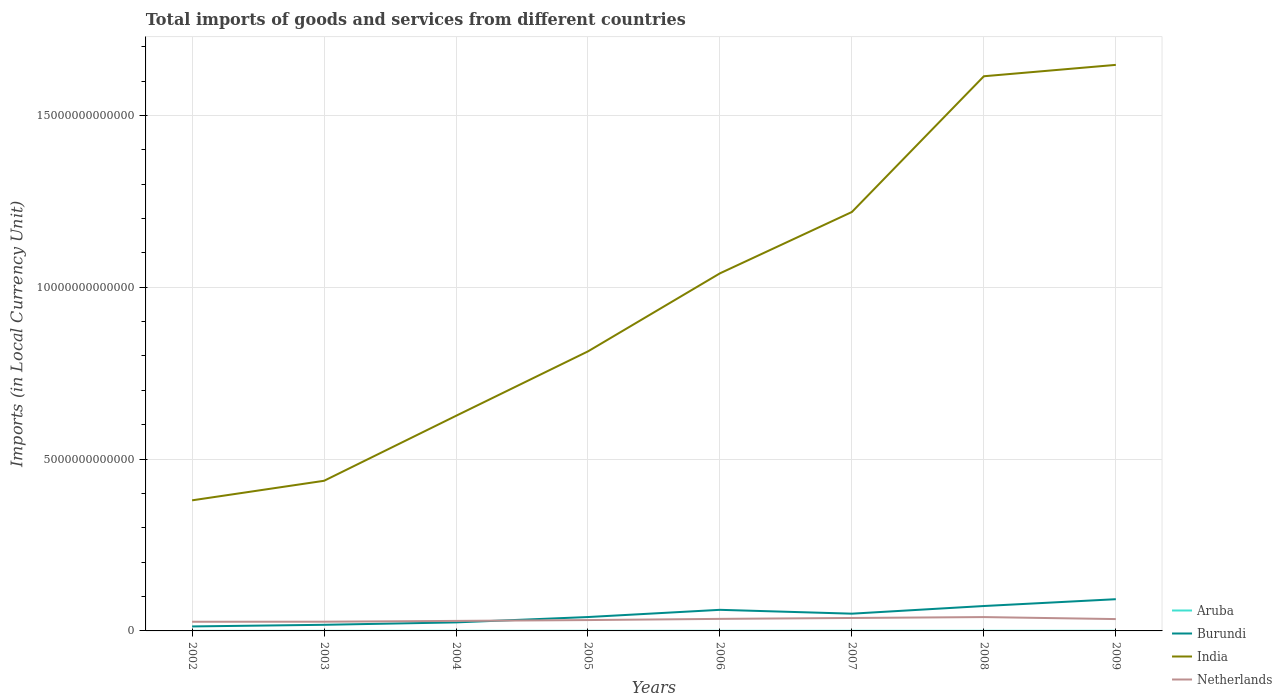Across all years, what is the maximum Amount of goods and services imports in India?
Ensure brevity in your answer.  3.80e+12. In which year was the Amount of goods and services imports in Burundi maximum?
Offer a very short reply. 2002. What is the total Amount of goods and services imports in Burundi in the graph?
Offer a terse response. -5.94e+11. What is the difference between the highest and the second highest Amount of goods and services imports in India?
Offer a terse response. 1.27e+13. What is the difference between the highest and the lowest Amount of goods and services imports in India?
Provide a succinct answer. 4. How many years are there in the graph?
Keep it short and to the point. 8. What is the difference between two consecutive major ticks on the Y-axis?
Give a very brief answer. 5.00e+12. Are the values on the major ticks of Y-axis written in scientific E-notation?
Provide a short and direct response. No. Does the graph contain grids?
Give a very brief answer. Yes. How many legend labels are there?
Provide a short and direct response. 4. What is the title of the graph?
Your response must be concise. Total imports of goods and services from different countries. Does "Middle income" appear as one of the legend labels in the graph?
Your response must be concise. No. What is the label or title of the X-axis?
Provide a short and direct response. Years. What is the label or title of the Y-axis?
Give a very brief answer. Imports (in Local Currency Unit). What is the Imports (in Local Currency Unit) of Aruba in 2002?
Provide a succinct answer. 2.41e+09. What is the Imports (in Local Currency Unit) of Burundi in 2002?
Make the answer very short. 1.31e+11. What is the Imports (in Local Currency Unit) in India in 2002?
Your answer should be very brief. 3.80e+12. What is the Imports (in Local Currency Unit) in Netherlands in 2002?
Offer a very short reply. 2.67e+11. What is the Imports (in Local Currency Unit) of Aruba in 2003?
Your response must be concise. 2.56e+09. What is the Imports (in Local Currency Unit) in Burundi in 2003?
Your answer should be compact. 1.78e+11. What is the Imports (in Local Currency Unit) of India in 2003?
Give a very brief answer. 4.37e+12. What is the Imports (in Local Currency Unit) of Netherlands in 2003?
Your response must be concise. 2.68e+11. What is the Imports (in Local Currency Unit) in Aruba in 2004?
Offer a terse response. 2.74e+09. What is the Imports (in Local Currency Unit) of Burundi in 2004?
Your response must be concise. 2.48e+11. What is the Imports (in Local Currency Unit) in India in 2004?
Provide a succinct answer. 6.26e+12. What is the Imports (in Local Currency Unit) of Netherlands in 2004?
Offer a very short reply. 2.91e+11. What is the Imports (in Local Currency Unit) in Aruba in 2005?
Ensure brevity in your answer.  3.25e+09. What is the Imports (in Local Currency Unit) in Burundi in 2005?
Offer a very short reply. 4.04e+11. What is the Imports (in Local Currency Unit) of India in 2005?
Your response must be concise. 8.13e+12. What is the Imports (in Local Currency Unit) of Netherlands in 2005?
Give a very brief answer. 3.16e+11. What is the Imports (in Local Currency Unit) in Aruba in 2006?
Ensure brevity in your answer.  3.38e+09. What is the Imports (in Local Currency Unit) in Burundi in 2006?
Your answer should be compact. 6.14e+11. What is the Imports (in Local Currency Unit) in India in 2006?
Your answer should be very brief. 1.04e+13. What is the Imports (in Local Currency Unit) in Netherlands in 2006?
Keep it short and to the point. 3.51e+11. What is the Imports (in Local Currency Unit) of Aruba in 2007?
Offer a terse response. 3.59e+09. What is the Imports (in Local Currency Unit) of Burundi in 2007?
Provide a short and direct response. 5.02e+11. What is the Imports (in Local Currency Unit) in India in 2007?
Provide a succinct answer. 1.22e+13. What is the Imports (in Local Currency Unit) in Netherlands in 2007?
Offer a terse response. 3.77e+11. What is the Imports (in Local Currency Unit) of Aruba in 2008?
Offer a terse response. 3.74e+09. What is the Imports (in Local Currency Unit) of Burundi in 2008?
Ensure brevity in your answer.  7.25e+11. What is the Imports (in Local Currency Unit) in India in 2008?
Provide a short and direct response. 1.61e+13. What is the Imports (in Local Currency Unit) in Netherlands in 2008?
Your response must be concise. 4.03e+11. What is the Imports (in Local Currency Unit) of Aruba in 2009?
Make the answer very short. 3.41e+09. What is the Imports (in Local Currency Unit) of Burundi in 2009?
Your answer should be compact. 9.23e+11. What is the Imports (in Local Currency Unit) of India in 2009?
Your answer should be compact. 1.65e+13. What is the Imports (in Local Currency Unit) in Netherlands in 2009?
Offer a terse response. 3.45e+11. Across all years, what is the maximum Imports (in Local Currency Unit) of Aruba?
Your response must be concise. 3.74e+09. Across all years, what is the maximum Imports (in Local Currency Unit) of Burundi?
Your response must be concise. 9.23e+11. Across all years, what is the maximum Imports (in Local Currency Unit) in India?
Make the answer very short. 1.65e+13. Across all years, what is the maximum Imports (in Local Currency Unit) in Netherlands?
Keep it short and to the point. 4.03e+11. Across all years, what is the minimum Imports (in Local Currency Unit) in Aruba?
Provide a succinct answer. 2.41e+09. Across all years, what is the minimum Imports (in Local Currency Unit) of Burundi?
Your response must be concise. 1.31e+11. Across all years, what is the minimum Imports (in Local Currency Unit) of India?
Offer a very short reply. 3.80e+12. Across all years, what is the minimum Imports (in Local Currency Unit) in Netherlands?
Make the answer very short. 2.67e+11. What is the total Imports (in Local Currency Unit) of Aruba in the graph?
Your answer should be compact. 2.51e+1. What is the total Imports (in Local Currency Unit) in Burundi in the graph?
Your response must be concise. 3.72e+12. What is the total Imports (in Local Currency Unit) in India in the graph?
Provide a succinct answer. 7.78e+13. What is the total Imports (in Local Currency Unit) in Netherlands in the graph?
Offer a terse response. 2.62e+12. What is the difference between the Imports (in Local Currency Unit) of Aruba in 2002 and that in 2003?
Keep it short and to the point. -1.52e+08. What is the difference between the Imports (in Local Currency Unit) of Burundi in 2002 and that in 2003?
Give a very brief answer. -4.78e+1. What is the difference between the Imports (in Local Currency Unit) of India in 2002 and that in 2003?
Give a very brief answer. -5.69e+11. What is the difference between the Imports (in Local Currency Unit) of Netherlands in 2002 and that in 2003?
Your answer should be compact. -1.43e+09. What is the difference between the Imports (in Local Currency Unit) of Aruba in 2002 and that in 2004?
Your response must be concise. -3.24e+08. What is the difference between the Imports (in Local Currency Unit) in Burundi in 2002 and that in 2004?
Make the answer very short. -1.18e+11. What is the difference between the Imports (in Local Currency Unit) of India in 2002 and that in 2004?
Your response must be concise. -2.46e+12. What is the difference between the Imports (in Local Currency Unit) of Netherlands in 2002 and that in 2004?
Keep it short and to the point. -2.45e+1. What is the difference between the Imports (in Local Currency Unit) of Aruba in 2002 and that in 2005?
Offer a terse response. -8.40e+08. What is the difference between the Imports (in Local Currency Unit) in Burundi in 2002 and that in 2005?
Ensure brevity in your answer.  -2.74e+11. What is the difference between the Imports (in Local Currency Unit) in India in 2002 and that in 2005?
Offer a terse response. -4.33e+12. What is the difference between the Imports (in Local Currency Unit) of Netherlands in 2002 and that in 2005?
Give a very brief answer. -4.93e+1. What is the difference between the Imports (in Local Currency Unit) in Aruba in 2002 and that in 2006?
Ensure brevity in your answer.  -9.68e+08. What is the difference between the Imports (in Local Currency Unit) of Burundi in 2002 and that in 2006?
Provide a succinct answer. -4.83e+11. What is the difference between the Imports (in Local Currency Unit) in India in 2002 and that in 2006?
Give a very brief answer. -6.61e+12. What is the difference between the Imports (in Local Currency Unit) in Netherlands in 2002 and that in 2006?
Offer a very short reply. -8.39e+1. What is the difference between the Imports (in Local Currency Unit) of Aruba in 2002 and that in 2007?
Offer a very short reply. -1.18e+09. What is the difference between the Imports (in Local Currency Unit) of Burundi in 2002 and that in 2007?
Offer a terse response. -3.72e+11. What is the difference between the Imports (in Local Currency Unit) in India in 2002 and that in 2007?
Offer a very short reply. -8.39e+12. What is the difference between the Imports (in Local Currency Unit) of Netherlands in 2002 and that in 2007?
Give a very brief answer. -1.10e+11. What is the difference between the Imports (in Local Currency Unit) in Aruba in 2002 and that in 2008?
Ensure brevity in your answer.  -1.33e+09. What is the difference between the Imports (in Local Currency Unit) in Burundi in 2002 and that in 2008?
Your answer should be very brief. -5.94e+11. What is the difference between the Imports (in Local Currency Unit) in India in 2002 and that in 2008?
Make the answer very short. -1.23e+13. What is the difference between the Imports (in Local Currency Unit) in Netherlands in 2002 and that in 2008?
Offer a terse response. -1.36e+11. What is the difference between the Imports (in Local Currency Unit) of Aruba in 2002 and that in 2009?
Ensure brevity in your answer.  -1.00e+09. What is the difference between the Imports (in Local Currency Unit) of Burundi in 2002 and that in 2009?
Ensure brevity in your answer.  -7.92e+11. What is the difference between the Imports (in Local Currency Unit) of India in 2002 and that in 2009?
Ensure brevity in your answer.  -1.27e+13. What is the difference between the Imports (in Local Currency Unit) of Netherlands in 2002 and that in 2009?
Your response must be concise. -7.79e+1. What is the difference between the Imports (in Local Currency Unit) in Aruba in 2003 and that in 2004?
Provide a short and direct response. -1.72e+08. What is the difference between the Imports (in Local Currency Unit) of Burundi in 2003 and that in 2004?
Offer a terse response. -6.98e+1. What is the difference between the Imports (in Local Currency Unit) of India in 2003 and that in 2004?
Ensure brevity in your answer.  -1.89e+12. What is the difference between the Imports (in Local Currency Unit) in Netherlands in 2003 and that in 2004?
Offer a terse response. -2.31e+1. What is the difference between the Imports (in Local Currency Unit) in Aruba in 2003 and that in 2005?
Make the answer very short. -6.88e+08. What is the difference between the Imports (in Local Currency Unit) in Burundi in 2003 and that in 2005?
Give a very brief answer. -2.26e+11. What is the difference between the Imports (in Local Currency Unit) in India in 2003 and that in 2005?
Provide a short and direct response. -3.77e+12. What is the difference between the Imports (in Local Currency Unit) in Netherlands in 2003 and that in 2005?
Your response must be concise. -4.79e+1. What is the difference between the Imports (in Local Currency Unit) of Aruba in 2003 and that in 2006?
Your response must be concise. -8.16e+08. What is the difference between the Imports (in Local Currency Unit) of Burundi in 2003 and that in 2006?
Keep it short and to the point. -4.36e+11. What is the difference between the Imports (in Local Currency Unit) in India in 2003 and that in 2006?
Keep it short and to the point. -6.04e+12. What is the difference between the Imports (in Local Currency Unit) of Netherlands in 2003 and that in 2006?
Offer a very short reply. -8.24e+1. What is the difference between the Imports (in Local Currency Unit) of Aruba in 2003 and that in 2007?
Your response must be concise. -1.03e+09. What is the difference between the Imports (in Local Currency Unit) in Burundi in 2003 and that in 2007?
Ensure brevity in your answer.  -3.24e+11. What is the difference between the Imports (in Local Currency Unit) in India in 2003 and that in 2007?
Make the answer very short. -7.82e+12. What is the difference between the Imports (in Local Currency Unit) in Netherlands in 2003 and that in 2007?
Give a very brief answer. -1.09e+11. What is the difference between the Imports (in Local Currency Unit) of Aruba in 2003 and that in 2008?
Your answer should be compact. -1.18e+09. What is the difference between the Imports (in Local Currency Unit) of Burundi in 2003 and that in 2008?
Offer a very short reply. -5.46e+11. What is the difference between the Imports (in Local Currency Unit) in India in 2003 and that in 2008?
Provide a succinct answer. -1.18e+13. What is the difference between the Imports (in Local Currency Unit) in Netherlands in 2003 and that in 2008?
Give a very brief answer. -1.35e+11. What is the difference between the Imports (in Local Currency Unit) in Aruba in 2003 and that in 2009?
Keep it short and to the point. -8.48e+08. What is the difference between the Imports (in Local Currency Unit) in Burundi in 2003 and that in 2009?
Give a very brief answer. -7.45e+11. What is the difference between the Imports (in Local Currency Unit) in India in 2003 and that in 2009?
Offer a very short reply. -1.21e+13. What is the difference between the Imports (in Local Currency Unit) in Netherlands in 2003 and that in 2009?
Your response must be concise. -7.65e+1. What is the difference between the Imports (in Local Currency Unit) in Aruba in 2004 and that in 2005?
Give a very brief answer. -5.17e+08. What is the difference between the Imports (in Local Currency Unit) in Burundi in 2004 and that in 2005?
Give a very brief answer. -1.56e+11. What is the difference between the Imports (in Local Currency Unit) of India in 2004 and that in 2005?
Your answer should be very brief. -1.88e+12. What is the difference between the Imports (in Local Currency Unit) in Netherlands in 2004 and that in 2005?
Your answer should be compact. -2.47e+1. What is the difference between the Imports (in Local Currency Unit) in Aruba in 2004 and that in 2006?
Ensure brevity in your answer.  -6.45e+08. What is the difference between the Imports (in Local Currency Unit) of Burundi in 2004 and that in 2006?
Your answer should be compact. -3.66e+11. What is the difference between the Imports (in Local Currency Unit) in India in 2004 and that in 2006?
Provide a succinct answer. -4.15e+12. What is the difference between the Imports (in Local Currency Unit) in Netherlands in 2004 and that in 2006?
Your answer should be compact. -5.93e+1. What is the difference between the Imports (in Local Currency Unit) of Aruba in 2004 and that in 2007?
Provide a short and direct response. -8.55e+08. What is the difference between the Imports (in Local Currency Unit) in Burundi in 2004 and that in 2007?
Provide a succinct answer. -2.54e+11. What is the difference between the Imports (in Local Currency Unit) in India in 2004 and that in 2007?
Provide a short and direct response. -5.93e+12. What is the difference between the Imports (in Local Currency Unit) in Netherlands in 2004 and that in 2007?
Your response must be concise. -8.55e+1. What is the difference between the Imports (in Local Currency Unit) of Aruba in 2004 and that in 2008?
Your answer should be very brief. -1.01e+09. What is the difference between the Imports (in Local Currency Unit) of Burundi in 2004 and that in 2008?
Keep it short and to the point. -4.77e+11. What is the difference between the Imports (in Local Currency Unit) of India in 2004 and that in 2008?
Your response must be concise. -9.88e+12. What is the difference between the Imports (in Local Currency Unit) in Netherlands in 2004 and that in 2008?
Provide a succinct answer. -1.11e+11. What is the difference between the Imports (in Local Currency Unit) of Aruba in 2004 and that in 2009?
Provide a succinct answer. -6.77e+08. What is the difference between the Imports (in Local Currency Unit) of Burundi in 2004 and that in 2009?
Ensure brevity in your answer.  -6.75e+11. What is the difference between the Imports (in Local Currency Unit) of India in 2004 and that in 2009?
Provide a short and direct response. -1.02e+13. What is the difference between the Imports (in Local Currency Unit) of Netherlands in 2004 and that in 2009?
Your answer should be compact. -5.34e+1. What is the difference between the Imports (in Local Currency Unit) in Aruba in 2005 and that in 2006?
Provide a succinct answer. -1.28e+08. What is the difference between the Imports (in Local Currency Unit) in Burundi in 2005 and that in 2006?
Keep it short and to the point. -2.10e+11. What is the difference between the Imports (in Local Currency Unit) in India in 2005 and that in 2006?
Offer a very short reply. -2.27e+12. What is the difference between the Imports (in Local Currency Unit) of Netherlands in 2005 and that in 2006?
Give a very brief answer. -3.46e+1. What is the difference between the Imports (in Local Currency Unit) in Aruba in 2005 and that in 2007?
Make the answer very short. -3.39e+08. What is the difference between the Imports (in Local Currency Unit) in Burundi in 2005 and that in 2007?
Your response must be concise. -9.80e+1. What is the difference between the Imports (in Local Currency Unit) in India in 2005 and that in 2007?
Your answer should be very brief. -4.06e+12. What is the difference between the Imports (in Local Currency Unit) of Netherlands in 2005 and that in 2007?
Your answer should be very brief. -6.07e+1. What is the difference between the Imports (in Local Currency Unit) in Aruba in 2005 and that in 2008?
Offer a terse response. -4.93e+08. What is the difference between the Imports (in Local Currency Unit) of Burundi in 2005 and that in 2008?
Your response must be concise. -3.21e+11. What is the difference between the Imports (in Local Currency Unit) of India in 2005 and that in 2008?
Keep it short and to the point. -8.01e+12. What is the difference between the Imports (in Local Currency Unit) in Netherlands in 2005 and that in 2008?
Provide a short and direct response. -8.67e+1. What is the difference between the Imports (in Local Currency Unit) of Aruba in 2005 and that in 2009?
Offer a terse response. -1.60e+08. What is the difference between the Imports (in Local Currency Unit) in Burundi in 2005 and that in 2009?
Keep it short and to the point. -5.19e+11. What is the difference between the Imports (in Local Currency Unit) of India in 2005 and that in 2009?
Offer a terse response. -8.34e+12. What is the difference between the Imports (in Local Currency Unit) of Netherlands in 2005 and that in 2009?
Your answer should be very brief. -2.86e+1. What is the difference between the Imports (in Local Currency Unit) in Aruba in 2006 and that in 2007?
Ensure brevity in your answer.  -2.11e+08. What is the difference between the Imports (in Local Currency Unit) of Burundi in 2006 and that in 2007?
Make the answer very short. 1.12e+11. What is the difference between the Imports (in Local Currency Unit) of India in 2006 and that in 2007?
Keep it short and to the point. -1.79e+12. What is the difference between the Imports (in Local Currency Unit) in Netherlands in 2006 and that in 2007?
Your answer should be compact. -2.62e+1. What is the difference between the Imports (in Local Currency Unit) in Aruba in 2006 and that in 2008?
Give a very brief answer. -3.65e+08. What is the difference between the Imports (in Local Currency Unit) in Burundi in 2006 and that in 2008?
Your response must be concise. -1.11e+11. What is the difference between the Imports (in Local Currency Unit) of India in 2006 and that in 2008?
Make the answer very short. -5.74e+12. What is the difference between the Imports (in Local Currency Unit) in Netherlands in 2006 and that in 2008?
Give a very brief answer. -5.21e+1. What is the difference between the Imports (in Local Currency Unit) of Aruba in 2006 and that in 2009?
Your answer should be compact. -3.22e+07. What is the difference between the Imports (in Local Currency Unit) in Burundi in 2006 and that in 2009?
Keep it short and to the point. -3.09e+11. What is the difference between the Imports (in Local Currency Unit) in India in 2006 and that in 2009?
Make the answer very short. -6.07e+12. What is the difference between the Imports (in Local Currency Unit) in Netherlands in 2006 and that in 2009?
Ensure brevity in your answer.  5.95e+09. What is the difference between the Imports (in Local Currency Unit) of Aruba in 2007 and that in 2008?
Offer a very short reply. -1.54e+08. What is the difference between the Imports (in Local Currency Unit) in Burundi in 2007 and that in 2008?
Keep it short and to the point. -2.23e+11. What is the difference between the Imports (in Local Currency Unit) in India in 2007 and that in 2008?
Ensure brevity in your answer.  -3.95e+12. What is the difference between the Imports (in Local Currency Unit) of Netherlands in 2007 and that in 2008?
Your answer should be very brief. -2.59e+1. What is the difference between the Imports (in Local Currency Unit) of Aruba in 2007 and that in 2009?
Keep it short and to the point. 1.79e+08. What is the difference between the Imports (in Local Currency Unit) in Burundi in 2007 and that in 2009?
Keep it short and to the point. -4.21e+11. What is the difference between the Imports (in Local Currency Unit) of India in 2007 and that in 2009?
Ensure brevity in your answer.  -4.28e+12. What is the difference between the Imports (in Local Currency Unit) of Netherlands in 2007 and that in 2009?
Give a very brief answer. 3.21e+1. What is the difference between the Imports (in Local Currency Unit) of Aruba in 2008 and that in 2009?
Provide a short and direct response. 3.33e+08. What is the difference between the Imports (in Local Currency Unit) in Burundi in 2008 and that in 2009?
Offer a very short reply. -1.98e+11. What is the difference between the Imports (in Local Currency Unit) of India in 2008 and that in 2009?
Make the answer very short. -3.31e+11. What is the difference between the Imports (in Local Currency Unit) of Netherlands in 2008 and that in 2009?
Offer a terse response. 5.80e+1. What is the difference between the Imports (in Local Currency Unit) in Aruba in 2002 and the Imports (in Local Currency Unit) in Burundi in 2003?
Give a very brief answer. -1.76e+11. What is the difference between the Imports (in Local Currency Unit) in Aruba in 2002 and the Imports (in Local Currency Unit) in India in 2003?
Ensure brevity in your answer.  -4.37e+12. What is the difference between the Imports (in Local Currency Unit) of Aruba in 2002 and the Imports (in Local Currency Unit) of Netherlands in 2003?
Offer a very short reply. -2.66e+11. What is the difference between the Imports (in Local Currency Unit) of Burundi in 2002 and the Imports (in Local Currency Unit) of India in 2003?
Provide a short and direct response. -4.24e+12. What is the difference between the Imports (in Local Currency Unit) in Burundi in 2002 and the Imports (in Local Currency Unit) in Netherlands in 2003?
Make the answer very short. -1.38e+11. What is the difference between the Imports (in Local Currency Unit) of India in 2002 and the Imports (in Local Currency Unit) of Netherlands in 2003?
Give a very brief answer. 3.53e+12. What is the difference between the Imports (in Local Currency Unit) of Aruba in 2002 and the Imports (in Local Currency Unit) of Burundi in 2004?
Make the answer very short. -2.46e+11. What is the difference between the Imports (in Local Currency Unit) in Aruba in 2002 and the Imports (in Local Currency Unit) in India in 2004?
Offer a very short reply. -6.26e+12. What is the difference between the Imports (in Local Currency Unit) of Aruba in 2002 and the Imports (in Local Currency Unit) of Netherlands in 2004?
Ensure brevity in your answer.  -2.89e+11. What is the difference between the Imports (in Local Currency Unit) in Burundi in 2002 and the Imports (in Local Currency Unit) in India in 2004?
Keep it short and to the point. -6.13e+12. What is the difference between the Imports (in Local Currency Unit) in Burundi in 2002 and the Imports (in Local Currency Unit) in Netherlands in 2004?
Provide a succinct answer. -1.61e+11. What is the difference between the Imports (in Local Currency Unit) of India in 2002 and the Imports (in Local Currency Unit) of Netherlands in 2004?
Ensure brevity in your answer.  3.51e+12. What is the difference between the Imports (in Local Currency Unit) in Aruba in 2002 and the Imports (in Local Currency Unit) in Burundi in 2005?
Keep it short and to the point. -4.02e+11. What is the difference between the Imports (in Local Currency Unit) of Aruba in 2002 and the Imports (in Local Currency Unit) of India in 2005?
Offer a terse response. -8.13e+12. What is the difference between the Imports (in Local Currency Unit) of Aruba in 2002 and the Imports (in Local Currency Unit) of Netherlands in 2005?
Provide a short and direct response. -3.14e+11. What is the difference between the Imports (in Local Currency Unit) in Burundi in 2002 and the Imports (in Local Currency Unit) in India in 2005?
Keep it short and to the point. -8.00e+12. What is the difference between the Imports (in Local Currency Unit) of Burundi in 2002 and the Imports (in Local Currency Unit) of Netherlands in 2005?
Keep it short and to the point. -1.86e+11. What is the difference between the Imports (in Local Currency Unit) of India in 2002 and the Imports (in Local Currency Unit) of Netherlands in 2005?
Give a very brief answer. 3.48e+12. What is the difference between the Imports (in Local Currency Unit) of Aruba in 2002 and the Imports (in Local Currency Unit) of Burundi in 2006?
Offer a terse response. -6.11e+11. What is the difference between the Imports (in Local Currency Unit) of Aruba in 2002 and the Imports (in Local Currency Unit) of India in 2006?
Provide a succinct answer. -1.04e+13. What is the difference between the Imports (in Local Currency Unit) in Aruba in 2002 and the Imports (in Local Currency Unit) in Netherlands in 2006?
Your response must be concise. -3.48e+11. What is the difference between the Imports (in Local Currency Unit) of Burundi in 2002 and the Imports (in Local Currency Unit) of India in 2006?
Give a very brief answer. -1.03e+13. What is the difference between the Imports (in Local Currency Unit) of Burundi in 2002 and the Imports (in Local Currency Unit) of Netherlands in 2006?
Make the answer very short. -2.20e+11. What is the difference between the Imports (in Local Currency Unit) of India in 2002 and the Imports (in Local Currency Unit) of Netherlands in 2006?
Offer a very short reply. 3.45e+12. What is the difference between the Imports (in Local Currency Unit) in Aruba in 2002 and the Imports (in Local Currency Unit) in Burundi in 2007?
Your response must be concise. -5.00e+11. What is the difference between the Imports (in Local Currency Unit) in Aruba in 2002 and the Imports (in Local Currency Unit) in India in 2007?
Your response must be concise. -1.22e+13. What is the difference between the Imports (in Local Currency Unit) in Aruba in 2002 and the Imports (in Local Currency Unit) in Netherlands in 2007?
Your answer should be compact. -3.74e+11. What is the difference between the Imports (in Local Currency Unit) of Burundi in 2002 and the Imports (in Local Currency Unit) of India in 2007?
Offer a terse response. -1.21e+13. What is the difference between the Imports (in Local Currency Unit) in Burundi in 2002 and the Imports (in Local Currency Unit) in Netherlands in 2007?
Keep it short and to the point. -2.46e+11. What is the difference between the Imports (in Local Currency Unit) of India in 2002 and the Imports (in Local Currency Unit) of Netherlands in 2007?
Provide a succinct answer. 3.42e+12. What is the difference between the Imports (in Local Currency Unit) of Aruba in 2002 and the Imports (in Local Currency Unit) of Burundi in 2008?
Provide a short and direct response. -7.22e+11. What is the difference between the Imports (in Local Currency Unit) of Aruba in 2002 and the Imports (in Local Currency Unit) of India in 2008?
Your answer should be compact. -1.61e+13. What is the difference between the Imports (in Local Currency Unit) of Aruba in 2002 and the Imports (in Local Currency Unit) of Netherlands in 2008?
Keep it short and to the point. -4.00e+11. What is the difference between the Imports (in Local Currency Unit) in Burundi in 2002 and the Imports (in Local Currency Unit) in India in 2008?
Ensure brevity in your answer.  -1.60e+13. What is the difference between the Imports (in Local Currency Unit) of Burundi in 2002 and the Imports (in Local Currency Unit) of Netherlands in 2008?
Offer a very short reply. -2.72e+11. What is the difference between the Imports (in Local Currency Unit) in India in 2002 and the Imports (in Local Currency Unit) in Netherlands in 2008?
Make the answer very short. 3.40e+12. What is the difference between the Imports (in Local Currency Unit) in Aruba in 2002 and the Imports (in Local Currency Unit) in Burundi in 2009?
Your response must be concise. -9.21e+11. What is the difference between the Imports (in Local Currency Unit) in Aruba in 2002 and the Imports (in Local Currency Unit) in India in 2009?
Provide a succinct answer. -1.65e+13. What is the difference between the Imports (in Local Currency Unit) in Aruba in 2002 and the Imports (in Local Currency Unit) in Netherlands in 2009?
Your response must be concise. -3.42e+11. What is the difference between the Imports (in Local Currency Unit) of Burundi in 2002 and the Imports (in Local Currency Unit) of India in 2009?
Make the answer very short. -1.63e+13. What is the difference between the Imports (in Local Currency Unit) of Burundi in 2002 and the Imports (in Local Currency Unit) of Netherlands in 2009?
Offer a terse response. -2.14e+11. What is the difference between the Imports (in Local Currency Unit) in India in 2002 and the Imports (in Local Currency Unit) in Netherlands in 2009?
Ensure brevity in your answer.  3.46e+12. What is the difference between the Imports (in Local Currency Unit) of Aruba in 2003 and the Imports (in Local Currency Unit) of Burundi in 2004?
Keep it short and to the point. -2.46e+11. What is the difference between the Imports (in Local Currency Unit) of Aruba in 2003 and the Imports (in Local Currency Unit) of India in 2004?
Ensure brevity in your answer.  -6.26e+12. What is the difference between the Imports (in Local Currency Unit) in Aruba in 2003 and the Imports (in Local Currency Unit) in Netherlands in 2004?
Ensure brevity in your answer.  -2.89e+11. What is the difference between the Imports (in Local Currency Unit) in Burundi in 2003 and the Imports (in Local Currency Unit) in India in 2004?
Ensure brevity in your answer.  -6.08e+12. What is the difference between the Imports (in Local Currency Unit) in Burundi in 2003 and the Imports (in Local Currency Unit) in Netherlands in 2004?
Your answer should be compact. -1.13e+11. What is the difference between the Imports (in Local Currency Unit) of India in 2003 and the Imports (in Local Currency Unit) of Netherlands in 2004?
Offer a very short reply. 4.08e+12. What is the difference between the Imports (in Local Currency Unit) of Aruba in 2003 and the Imports (in Local Currency Unit) of Burundi in 2005?
Offer a terse response. -4.02e+11. What is the difference between the Imports (in Local Currency Unit) in Aruba in 2003 and the Imports (in Local Currency Unit) in India in 2005?
Provide a short and direct response. -8.13e+12. What is the difference between the Imports (in Local Currency Unit) in Aruba in 2003 and the Imports (in Local Currency Unit) in Netherlands in 2005?
Your response must be concise. -3.14e+11. What is the difference between the Imports (in Local Currency Unit) of Burundi in 2003 and the Imports (in Local Currency Unit) of India in 2005?
Ensure brevity in your answer.  -7.96e+12. What is the difference between the Imports (in Local Currency Unit) in Burundi in 2003 and the Imports (in Local Currency Unit) in Netherlands in 2005?
Keep it short and to the point. -1.38e+11. What is the difference between the Imports (in Local Currency Unit) in India in 2003 and the Imports (in Local Currency Unit) in Netherlands in 2005?
Keep it short and to the point. 4.05e+12. What is the difference between the Imports (in Local Currency Unit) in Aruba in 2003 and the Imports (in Local Currency Unit) in Burundi in 2006?
Make the answer very short. -6.11e+11. What is the difference between the Imports (in Local Currency Unit) in Aruba in 2003 and the Imports (in Local Currency Unit) in India in 2006?
Offer a very short reply. -1.04e+13. What is the difference between the Imports (in Local Currency Unit) of Aruba in 2003 and the Imports (in Local Currency Unit) of Netherlands in 2006?
Your answer should be compact. -3.48e+11. What is the difference between the Imports (in Local Currency Unit) of Burundi in 2003 and the Imports (in Local Currency Unit) of India in 2006?
Give a very brief answer. -1.02e+13. What is the difference between the Imports (in Local Currency Unit) of Burundi in 2003 and the Imports (in Local Currency Unit) of Netherlands in 2006?
Offer a terse response. -1.72e+11. What is the difference between the Imports (in Local Currency Unit) of India in 2003 and the Imports (in Local Currency Unit) of Netherlands in 2006?
Provide a short and direct response. 4.02e+12. What is the difference between the Imports (in Local Currency Unit) of Aruba in 2003 and the Imports (in Local Currency Unit) of Burundi in 2007?
Give a very brief answer. -5.00e+11. What is the difference between the Imports (in Local Currency Unit) of Aruba in 2003 and the Imports (in Local Currency Unit) of India in 2007?
Keep it short and to the point. -1.22e+13. What is the difference between the Imports (in Local Currency Unit) of Aruba in 2003 and the Imports (in Local Currency Unit) of Netherlands in 2007?
Give a very brief answer. -3.74e+11. What is the difference between the Imports (in Local Currency Unit) in Burundi in 2003 and the Imports (in Local Currency Unit) in India in 2007?
Your answer should be very brief. -1.20e+13. What is the difference between the Imports (in Local Currency Unit) of Burundi in 2003 and the Imports (in Local Currency Unit) of Netherlands in 2007?
Provide a succinct answer. -1.99e+11. What is the difference between the Imports (in Local Currency Unit) in India in 2003 and the Imports (in Local Currency Unit) in Netherlands in 2007?
Offer a very short reply. 3.99e+12. What is the difference between the Imports (in Local Currency Unit) of Aruba in 2003 and the Imports (in Local Currency Unit) of Burundi in 2008?
Offer a terse response. -7.22e+11. What is the difference between the Imports (in Local Currency Unit) of Aruba in 2003 and the Imports (in Local Currency Unit) of India in 2008?
Provide a short and direct response. -1.61e+13. What is the difference between the Imports (in Local Currency Unit) of Aruba in 2003 and the Imports (in Local Currency Unit) of Netherlands in 2008?
Your answer should be very brief. -4.00e+11. What is the difference between the Imports (in Local Currency Unit) in Burundi in 2003 and the Imports (in Local Currency Unit) in India in 2008?
Provide a short and direct response. -1.60e+13. What is the difference between the Imports (in Local Currency Unit) of Burundi in 2003 and the Imports (in Local Currency Unit) of Netherlands in 2008?
Your answer should be compact. -2.24e+11. What is the difference between the Imports (in Local Currency Unit) in India in 2003 and the Imports (in Local Currency Unit) in Netherlands in 2008?
Provide a short and direct response. 3.97e+12. What is the difference between the Imports (in Local Currency Unit) in Aruba in 2003 and the Imports (in Local Currency Unit) in Burundi in 2009?
Give a very brief answer. -9.20e+11. What is the difference between the Imports (in Local Currency Unit) of Aruba in 2003 and the Imports (in Local Currency Unit) of India in 2009?
Offer a very short reply. -1.65e+13. What is the difference between the Imports (in Local Currency Unit) of Aruba in 2003 and the Imports (in Local Currency Unit) of Netherlands in 2009?
Keep it short and to the point. -3.42e+11. What is the difference between the Imports (in Local Currency Unit) in Burundi in 2003 and the Imports (in Local Currency Unit) in India in 2009?
Your answer should be compact. -1.63e+13. What is the difference between the Imports (in Local Currency Unit) of Burundi in 2003 and the Imports (in Local Currency Unit) of Netherlands in 2009?
Provide a short and direct response. -1.66e+11. What is the difference between the Imports (in Local Currency Unit) in India in 2003 and the Imports (in Local Currency Unit) in Netherlands in 2009?
Your answer should be compact. 4.02e+12. What is the difference between the Imports (in Local Currency Unit) in Aruba in 2004 and the Imports (in Local Currency Unit) in Burundi in 2005?
Provide a short and direct response. -4.01e+11. What is the difference between the Imports (in Local Currency Unit) of Aruba in 2004 and the Imports (in Local Currency Unit) of India in 2005?
Provide a short and direct response. -8.13e+12. What is the difference between the Imports (in Local Currency Unit) in Aruba in 2004 and the Imports (in Local Currency Unit) in Netherlands in 2005?
Keep it short and to the point. -3.13e+11. What is the difference between the Imports (in Local Currency Unit) of Burundi in 2004 and the Imports (in Local Currency Unit) of India in 2005?
Provide a succinct answer. -7.89e+12. What is the difference between the Imports (in Local Currency Unit) of Burundi in 2004 and the Imports (in Local Currency Unit) of Netherlands in 2005?
Your response must be concise. -6.80e+1. What is the difference between the Imports (in Local Currency Unit) in India in 2004 and the Imports (in Local Currency Unit) in Netherlands in 2005?
Provide a short and direct response. 5.94e+12. What is the difference between the Imports (in Local Currency Unit) in Aruba in 2004 and the Imports (in Local Currency Unit) in Burundi in 2006?
Your response must be concise. -6.11e+11. What is the difference between the Imports (in Local Currency Unit) of Aruba in 2004 and the Imports (in Local Currency Unit) of India in 2006?
Your answer should be very brief. -1.04e+13. What is the difference between the Imports (in Local Currency Unit) in Aruba in 2004 and the Imports (in Local Currency Unit) in Netherlands in 2006?
Keep it short and to the point. -3.48e+11. What is the difference between the Imports (in Local Currency Unit) in Burundi in 2004 and the Imports (in Local Currency Unit) in India in 2006?
Provide a short and direct response. -1.02e+13. What is the difference between the Imports (in Local Currency Unit) of Burundi in 2004 and the Imports (in Local Currency Unit) of Netherlands in 2006?
Provide a short and direct response. -1.03e+11. What is the difference between the Imports (in Local Currency Unit) in India in 2004 and the Imports (in Local Currency Unit) in Netherlands in 2006?
Offer a very short reply. 5.91e+12. What is the difference between the Imports (in Local Currency Unit) of Aruba in 2004 and the Imports (in Local Currency Unit) of Burundi in 2007?
Offer a terse response. -4.99e+11. What is the difference between the Imports (in Local Currency Unit) in Aruba in 2004 and the Imports (in Local Currency Unit) in India in 2007?
Ensure brevity in your answer.  -1.22e+13. What is the difference between the Imports (in Local Currency Unit) of Aruba in 2004 and the Imports (in Local Currency Unit) of Netherlands in 2007?
Offer a terse response. -3.74e+11. What is the difference between the Imports (in Local Currency Unit) of Burundi in 2004 and the Imports (in Local Currency Unit) of India in 2007?
Provide a succinct answer. -1.19e+13. What is the difference between the Imports (in Local Currency Unit) of Burundi in 2004 and the Imports (in Local Currency Unit) of Netherlands in 2007?
Your answer should be very brief. -1.29e+11. What is the difference between the Imports (in Local Currency Unit) in India in 2004 and the Imports (in Local Currency Unit) in Netherlands in 2007?
Offer a terse response. 5.88e+12. What is the difference between the Imports (in Local Currency Unit) of Aruba in 2004 and the Imports (in Local Currency Unit) of Burundi in 2008?
Ensure brevity in your answer.  -7.22e+11. What is the difference between the Imports (in Local Currency Unit) of Aruba in 2004 and the Imports (in Local Currency Unit) of India in 2008?
Your response must be concise. -1.61e+13. What is the difference between the Imports (in Local Currency Unit) in Aruba in 2004 and the Imports (in Local Currency Unit) in Netherlands in 2008?
Offer a very short reply. -4.00e+11. What is the difference between the Imports (in Local Currency Unit) in Burundi in 2004 and the Imports (in Local Currency Unit) in India in 2008?
Keep it short and to the point. -1.59e+13. What is the difference between the Imports (in Local Currency Unit) in Burundi in 2004 and the Imports (in Local Currency Unit) in Netherlands in 2008?
Keep it short and to the point. -1.55e+11. What is the difference between the Imports (in Local Currency Unit) of India in 2004 and the Imports (in Local Currency Unit) of Netherlands in 2008?
Your answer should be very brief. 5.86e+12. What is the difference between the Imports (in Local Currency Unit) of Aruba in 2004 and the Imports (in Local Currency Unit) of Burundi in 2009?
Your answer should be very brief. -9.20e+11. What is the difference between the Imports (in Local Currency Unit) of Aruba in 2004 and the Imports (in Local Currency Unit) of India in 2009?
Your response must be concise. -1.65e+13. What is the difference between the Imports (in Local Currency Unit) in Aruba in 2004 and the Imports (in Local Currency Unit) in Netherlands in 2009?
Offer a very short reply. -3.42e+11. What is the difference between the Imports (in Local Currency Unit) of Burundi in 2004 and the Imports (in Local Currency Unit) of India in 2009?
Make the answer very short. -1.62e+13. What is the difference between the Imports (in Local Currency Unit) in Burundi in 2004 and the Imports (in Local Currency Unit) in Netherlands in 2009?
Your answer should be compact. -9.66e+1. What is the difference between the Imports (in Local Currency Unit) of India in 2004 and the Imports (in Local Currency Unit) of Netherlands in 2009?
Offer a terse response. 5.91e+12. What is the difference between the Imports (in Local Currency Unit) of Aruba in 2005 and the Imports (in Local Currency Unit) of Burundi in 2006?
Make the answer very short. -6.11e+11. What is the difference between the Imports (in Local Currency Unit) of Aruba in 2005 and the Imports (in Local Currency Unit) of India in 2006?
Offer a terse response. -1.04e+13. What is the difference between the Imports (in Local Currency Unit) in Aruba in 2005 and the Imports (in Local Currency Unit) in Netherlands in 2006?
Ensure brevity in your answer.  -3.47e+11. What is the difference between the Imports (in Local Currency Unit) in Burundi in 2005 and the Imports (in Local Currency Unit) in India in 2006?
Your answer should be very brief. -1.00e+13. What is the difference between the Imports (in Local Currency Unit) in Burundi in 2005 and the Imports (in Local Currency Unit) in Netherlands in 2006?
Provide a succinct answer. 5.34e+1. What is the difference between the Imports (in Local Currency Unit) of India in 2005 and the Imports (in Local Currency Unit) of Netherlands in 2006?
Your answer should be compact. 7.78e+12. What is the difference between the Imports (in Local Currency Unit) of Aruba in 2005 and the Imports (in Local Currency Unit) of Burundi in 2007?
Provide a short and direct response. -4.99e+11. What is the difference between the Imports (in Local Currency Unit) in Aruba in 2005 and the Imports (in Local Currency Unit) in India in 2007?
Your answer should be compact. -1.22e+13. What is the difference between the Imports (in Local Currency Unit) in Aruba in 2005 and the Imports (in Local Currency Unit) in Netherlands in 2007?
Make the answer very short. -3.74e+11. What is the difference between the Imports (in Local Currency Unit) of Burundi in 2005 and the Imports (in Local Currency Unit) of India in 2007?
Provide a succinct answer. -1.18e+13. What is the difference between the Imports (in Local Currency Unit) in Burundi in 2005 and the Imports (in Local Currency Unit) in Netherlands in 2007?
Ensure brevity in your answer.  2.73e+1. What is the difference between the Imports (in Local Currency Unit) in India in 2005 and the Imports (in Local Currency Unit) in Netherlands in 2007?
Make the answer very short. 7.76e+12. What is the difference between the Imports (in Local Currency Unit) in Aruba in 2005 and the Imports (in Local Currency Unit) in Burundi in 2008?
Provide a short and direct response. -7.21e+11. What is the difference between the Imports (in Local Currency Unit) in Aruba in 2005 and the Imports (in Local Currency Unit) in India in 2008?
Provide a short and direct response. -1.61e+13. What is the difference between the Imports (in Local Currency Unit) of Aruba in 2005 and the Imports (in Local Currency Unit) of Netherlands in 2008?
Offer a very short reply. -4.00e+11. What is the difference between the Imports (in Local Currency Unit) in Burundi in 2005 and the Imports (in Local Currency Unit) in India in 2008?
Offer a terse response. -1.57e+13. What is the difference between the Imports (in Local Currency Unit) of Burundi in 2005 and the Imports (in Local Currency Unit) of Netherlands in 2008?
Make the answer very short. 1.37e+09. What is the difference between the Imports (in Local Currency Unit) of India in 2005 and the Imports (in Local Currency Unit) of Netherlands in 2008?
Your answer should be very brief. 7.73e+12. What is the difference between the Imports (in Local Currency Unit) in Aruba in 2005 and the Imports (in Local Currency Unit) in Burundi in 2009?
Keep it short and to the point. -9.20e+11. What is the difference between the Imports (in Local Currency Unit) in Aruba in 2005 and the Imports (in Local Currency Unit) in India in 2009?
Provide a short and direct response. -1.65e+13. What is the difference between the Imports (in Local Currency Unit) of Aruba in 2005 and the Imports (in Local Currency Unit) of Netherlands in 2009?
Provide a succinct answer. -3.41e+11. What is the difference between the Imports (in Local Currency Unit) of Burundi in 2005 and the Imports (in Local Currency Unit) of India in 2009?
Give a very brief answer. -1.61e+13. What is the difference between the Imports (in Local Currency Unit) in Burundi in 2005 and the Imports (in Local Currency Unit) in Netherlands in 2009?
Offer a very short reply. 5.94e+1. What is the difference between the Imports (in Local Currency Unit) in India in 2005 and the Imports (in Local Currency Unit) in Netherlands in 2009?
Offer a terse response. 7.79e+12. What is the difference between the Imports (in Local Currency Unit) of Aruba in 2006 and the Imports (in Local Currency Unit) of Burundi in 2007?
Your response must be concise. -4.99e+11. What is the difference between the Imports (in Local Currency Unit) in Aruba in 2006 and the Imports (in Local Currency Unit) in India in 2007?
Your answer should be very brief. -1.22e+13. What is the difference between the Imports (in Local Currency Unit) of Aruba in 2006 and the Imports (in Local Currency Unit) of Netherlands in 2007?
Provide a succinct answer. -3.73e+11. What is the difference between the Imports (in Local Currency Unit) in Burundi in 2006 and the Imports (in Local Currency Unit) in India in 2007?
Provide a short and direct response. -1.16e+13. What is the difference between the Imports (in Local Currency Unit) of Burundi in 2006 and the Imports (in Local Currency Unit) of Netherlands in 2007?
Your answer should be compact. 2.37e+11. What is the difference between the Imports (in Local Currency Unit) in India in 2006 and the Imports (in Local Currency Unit) in Netherlands in 2007?
Your answer should be compact. 1.00e+13. What is the difference between the Imports (in Local Currency Unit) of Aruba in 2006 and the Imports (in Local Currency Unit) of Burundi in 2008?
Your answer should be compact. -7.21e+11. What is the difference between the Imports (in Local Currency Unit) in Aruba in 2006 and the Imports (in Local Currency Unit) in India in 2008?
Keep it short and to the point. -1.61e+13. What is the difference between the Imports (in Local Currency Unit) of Aruba in 2006 and the Imports (in Local Currency Unit) of Netherlands in 2008?
Make the answer very short. -3.99e+11. What is the difference between the Imports (in Local Currency Unit) in Burundi in 2006 and the Imports (in Local Currency Unit) in India in 2008?
Ensure brevity in your answer.  -1.55e+13. What is the difference between the Imports (in Local Currency Unit) in Burundi in 2006 and the Imports (in Local Currency Unit) in Netherlands in 2008?
Your answer should be very brief. 2.11e+11. What is the difference between the Imports (in Local Currency Unit) of India in 2006 and the Imports (in Local Currency Unit) of Netherlands in 2008?
Offer a terse response. 1.00e+13. What is the difference between the Imports (in Local Currency Unit) in Aruba in 2006 and the Imports (in Local Currency Unit) in Burundi in 2009?
Offer a very short reply. -9.20e+11. What is the difference between the Imports (in Local Currency Unit) of Aruba in 2006 and the Imports (in Local Currency Unit) of India in 2009?
Offer a very short reply. -1.65e+13. What is the difference between the Imports (in Local Currency Unit) in Aruba in 2006 and the Imports (in Local Currency Unit) in Netherlands in 2009?
Keep it short and to the point. -3.41e+11. What is the difference between the Imports (in Local Currency Unit) of Burundi in 2006 and the Imports (in Local Currency Unit) of India in 2009?
Offer a very short reply. -1.59e+13. What is the difference between the Imports (in Local Currency Unit) in Burundi in 2006 and the Imports (in Local Currency Unit) in Netherlands in 2009?
Your answer should be very brief. 2.69e+11. What is the difference between the Imports (in Local Currency Unit) of India in 2006 and the Imports (in Local Currency Unit) of Netherlands in 2009?
Provide a succinct answer. 1.01e+13. What is the difference between the Imports (in Local Currency Unit) in Aruba in 2007 and the Imports (in Local Currency Unit) in Burundi in 2008?
Offer a terse response. -7.21e+11. What is the difference between the Imports (in Local Currency Unit) in Aruba in 2007 and the Imports (in Local Currency Unit) in India in 2008?
Offer a terse response. -1.61e+13. What is the difference between the Imports (in Local Currency Unit) in Aruba in 2007 and the Imports (in Local Currency Unit) in Netherlands in 2008?
Your response must be concise. -3.99e+11. What is the difference between the Imports (in Local Currency Unit) of Burundi in 2007 and the Imports (in Local Currency Unit) of India in 2008?
Make the answer very short. -1.56e+13. What is the difference between the Imports (in Local Currency Unit) in Burundi in 2007 and the Imports (in Local Currency Unit) in Netherlands in 2008?
Keep it short and to the point. 9.93e+1. What is the difference between the Imports (in Local Currency Unit) in India in 2007 and the Imports (in Local Currency Unit) in Netherlands in 2008?
Your answer should be compact. 1.18e+13. What is the difference between the Imports (in Local Currency Unit) of Aruba in 2007 and the Imports (in Local Currency Unit) of Burundi in 2009?
Provide a succinct answer. -9.19e+11. What is the difference between the Imports (in Local Currency Unit) of Aruba in 2007 and the Imports (in Local Currency Unit) of India in 2009?
Your answer should be very brief. -1.65e+13. What is the difference between the Imports (in Local Currency Unit) in Aruba in 2007 and the Imports (in Local Currency Unit) in Netherlands in 2009?
Offer a terse response. -3.41e+11. What is the difference between the Imports (in Local Currency Unit) in Burundi in 2007 and the Imports (in Local Currency Unit) in India in 2009?
Your answer should be compact. -1.60e+13. What is the difference between the Imports (in Local Currency Unit) of Burundi in 2007 and the Imports (in Local Currency Unit) of Netherlands in 2009?
Provide a succinct answer. 1.57e+11. What is the difference between the Imports (in Local Currency Unit) of India in 2007 and the Imports (in Local Currency Unit) of Netherlands in 2009?
Your response must be concise. 1.18e+13. What is the difference between the Imports (in Local Currency Unit) of Aruba in 2008 and the Imports (in Local Currency Unit) of Burundi in 2009?
Your answer should be very brief. -9.19e+11. What is the difference between the Imports (in Local Currency Unit) of Aruba in 2008 and the Imports (in Local Currency Unit) of India in 2009?
Give a very brief answer. -1.65e+13. What is the difference between the Imports (in Local Currency Unit) in Aruba in 2008 and the Imports (in Local Currency Unit) in Netherlands in 2009?
Your answer should be very brief. -3.41e+11. What is the difference between the Imports (in Local Currency Unit) in Burundi in 2008 and the Imports (in Local Currency Unit) in India in 2009?
Your response must be concise. -1.57e+13. What is the difference between the Imports (in Local Currency Unit) in Burundi in 2008 and the Imports (in Local Currency Unit) in Netherlands in 2009?
Keep it short and to the point. 3.80e+11. What is the difference between the Imports (in Local Currency Unit) in India in 2008 and the Imports (in Local Currency Unit) in Netherlands in 2009?
Your answer should be very brief. 1.58e+13. What is the average Imports (in Local Currency Unit) of Aruba per year?
Offer a very short reply. 3.14e+09. What is the average Imports (in Local Currency Unit) in Burundi per year?
Keep it short and to the point. 4.66e+11. What is the average Imports (in Local Currency Unit) in India per year?
Ensure brevity in your answer.  9.72e+12. What is the average Imports (in Local Currency Unit) of Netherlands per year?
Make the answer very short. 3.27e+11. In the year 2002, what is the difference between the Imports (in Local Currency Unit) of Aruba and Imports (in Local Currency Unit) of Burundi?
Your response must be concise. -1.28e+11. In the year 2002, what is the difference between the Imports (in Local Currency Unit) in Aruba and Imports (in Local Currency Unit) in India?
Provide a succinct answer. -3.80e+12. In the year 2002, what is the difference between the Imports (in Local Currency Unit) in Aruba and Imports (in Local Currency Unit) in Netherlands?
Give a very brief answer. -2.64e+11. In the year 2002, what is the difference between the Imports (in Local Currency Unit) of Burundi and Imports (in Local Currency Unit) of India?
Make the answer very short. -3.67e+12. In the year 2002, what is the difference between the Imports (in Local Currency Unit) in Burundi and Imports (in Local Currency Unit) in Netherlands?
Provide a short and direct response. -1.36e+11. In the year 2002, what is the difference between the Imports (in Local Currency Unit) of India and Imports (in Local Currency Unit) of Netherlands?
Your answer should be compact. 3.53e+12. In the year 2003, what is the difference between the Imports (in Local Currency Unit) in Aruba and Imports (in Local Currency Unit) in Burundi?
Your response must be concise. -1.76e+11. In the year 2003, what is the difference between the Imports (in Local Currency Unit) in Aruba and Imports (in Local Currency Unit) in India?
Offer a terse response. -4.37e+12. In the year 2003, what is the difference between the Imports (in Local Currency Unit) of Aruba and Imports (in Local Currency Unit) of Netherlands?
Offer a very short reply. -2.66e+11. In the year 2003, what is the difference between the Imports (in Local Currency Unit) in Burundi and Imports (in Local Currency Unit) in India?
Give a very brief answer. -4.19e+12. In the year 2003, what is the difference between the Imports (in Local Currency Unit) in Burundi and Imports (in Local Currency Unit) in Netherlands?
Keep it short and to the point. -8.99e+1. In the year 2003, what is the difference between the Imports (in Local Currency Unit) in India and Imports (in Local Currency Unit) in Netherlands?
Provide a short and direct response. 4.10e+12. In the year 2004, what is the difference between the Imports (in Local Currency Unit) of Aruba and Imports (in Local Currency Unit) of Burundi?
Your response must be concise. -2.45e+11. In the year 2004, what is the difference between the Imports (in Local Currency Unit) in Aruba and Imports (in Local Currency Unit) in India?
Make the answer very short. -6.26e+12. In the year 2004, what is the difference between the Imports (in Local Currency Unit) of Aruba and Imports (in Local Currency Unit) of Netherlands?
Give a very brief answer. -2.89e+11. In the year 2004, what is the difference between the Imports (in Local Currency Unit) in Burundi and Imports (in Local Currency Unit) in India?
Provide a succinct answer. -6.01e+12. In the year 2004, what is the difference between the Imports (in Local Currency Unit) of Burundi and Imports (in Local Currency Unit) of Netherlands?
Give a very brief answer. -4.33e+1. In the year 2004, what is the difference between the Imports (in Local Currency Unit) in India and Imports (in Local Currency Unit) in Netherlands?
Offer a very short reply. 5.97e+12. In the year 2005, what is the difference between the Imports (in Local Currency Unit) in Aruba and Imports (in Local Currency Unit) in Burundi?
Offer a very short reply. -4.01e+11. In the year 2005, what is the difference between the Imports (in Local Currency Unit) in Aruba and Imports (in Local Currency Unit) in India?
Your answer should be compact. -8.13e+12. In the year 2005, what is the difference between the Imports (in Local Currency Unit) in Aruba and Imports (in Local Currency Unit) in Netherlands?
Offer a terse response. -3.13e+11. In the year 2005, what is the difference between the Imports (in Local Currency Unit) of Burundi and Imports (in Local Currency Unit) of India?
Give a very brief answer. -7.73e+12. In the year 2005, what is the difference between the Imports (in Local Currency Unit) of Burundi and Imports (in Local Currency Unit) of Netherlands?
Your answer should be very brief. 8.80e+1. In the year 2005, what is the difference between the Imports (in Local Currency Unit) of India and Imports (in Local Currency Unit) of Netherlands?
Offer a very short reply. 7.82e+12. In the year 2006, what is the difference between the Imports (in Local Currency Unit) in Aruba and Imports (in Local Currency Unit) in Burundi?
Keep it short and to the point. -6.10e+11. In the year 2006, what is the difference between the Imports (in Local Currency Unit) of Aruba and Imports (in Local Currency Unit) of India?
Your answer should be very brief. -1.04e+13. In the year 2006, what is the difference between the Imports (in Local Currency Unit) of Aruba and Imports (in Local Currency Unit) of Netherlands?
Your response must be concise. -3.47e+11. In the year 2006, what is the difference between the Imports (in Local Currency Unit) of Burundi and Imports (in Local Currency Unit) of India?
Your answer should be very brief. -9.79e+12. In the year 2006, what is the difference between the Imports (in Local Currency Unit) of Burundi and Imports (in Local Currency Unit) of Netherlands?
Your answer should be very brief. 2.63e+11. In the year 2006, what is the difference between the Imports (in Local Currency Unit) of India and Imports (in Local Currency Unit) of Netherlands?
Make the answer very short. 1.01e+13. In the year 2007, what is the difference between the Imports (in Local Currency Unit) in Aruba and Imports (in Local Currency Unit) in Burundi?
Your answer should be very brief. -4.99e+11. In the year 2007, what is the difference between the Imports (in Local Currency Unit) of Aruba and Imports (in Local Currency Unit) of India?
Offer a very short reply. -1.22e+13. In the year 2007, what is the difference between the Imports (in Local Currency Unit) of Aruba and Imports (in Local Currency Unit) of Netherlands?
Offer a very short reply. -3.73e+11. In the year 2007, what is the difference between the Imports (in Local Currency Unit) in Burundi and Imports (in Local Currency Unit) in India?
Your answer should be very brief. -1.17e+13. In the year 2007, what is the difference between the Imports (in Local Currency Unit) in Burundi and Imports (in Local Currency Unit) in Netherlands?
Make the answer very short. 1.25e+11. In the year 2007, what is the difference between the Imports (in Local Currency Unit) in India and Imports (in Local Currency Unit) in Netherlands?
Offer a very short reply. 1.18e+13. In the year 2008, what is the difference between the Imports (in Local Currency Unit) in Aruba and Imports (in Local Currency Unit) in Burundi?
Your response must be concise. -7.21e+11. In the year 2008, what is the difference between the Imports (in Local Currency Unit) of Aruba and Imports (in Local Currency Unit) of India?
Your answer should be compact. -1.61e+13. In the year 2008, what is the difference between the Imports (in Local Currency Unit) in Aruba and Imports (in Local Currency Unit) in Netherlands?
Your response must be concise. -3.99e+11. In the year 2008, what is the difference between the Imports (in Local Currency Unit) of Burundi and Imports (in Local Currency Unit) of India?
Offer a terse response. -1.54e+13. In the year 2008, what is the difference between the Imports (in Local Currency Unit) of Burundi and Imports (in Local Currency Unit) of Netherlands?
Your response must be concise. 3.22e+11. In the year 2008, what is the difference between the Imports (in Local Currency Unit) of India and Imports (in Local Currency Unit) of Netherlands?
Give a very brief answer. 1.57e+13. In the year 2009, what is the difference between the Imports (in Local Currency Unit) in Aruba and Imports (in Local Currency Unit) in Burundi?
Give a very brief answer. -9.20e+11. In the year 2009, what is the difference between the Imports (in Local Currency Unit) of Aruba and Imports (in Local Currency Unit) of India?
Offer a terse response. -1.65e+13. In the year 2009, what is the difference between the Imports (in Local Currency Unit) of Aruba and Imports (in Local Currency Unit) of Netherlands?
Provide a short and direct response. -3.41e+11. In the year 2009, what is the difference between the Imports (in Local Currency Unit) of Burundi and Imports (in Local Currency Unit) of India?
Your answer should be compact. -1.55e+13. In the year 2009, what is the difference between the Imports (in Local Currency Unit) of Burundi and Imports (in Local Currency Unit) of Netherlands?
Ensure brevity in your answer.  5.78e+11. In the year 2009, what is the difference between the Imports (in Local Currency Unit) in India and Imports (in Local Currency Unit) in Netherlands?
Your response must be concise. 1.61e+13. What is the ratio of the Imports (in Local Currency Unit) in Aruba in 2002 to that in 2003?
Give a very brief answer. 0.94. What is the ratio of the Imports (in Local Currency Unit) in Burundi in 2002 to that in 2003?
Provide a succinct answer. 0.73. What is the ratio of the Imports (in Local Currency Unit) of India in 2002 to that in 2003?
Provide a succinct answer. 0.87. What is the ratio of the Imports (in Local Currency Unit) in Netherlands in 2002 to that in 2003?
Provide a succinct answer. 0.99. What is the ratio of the Imports (in Local Currency Unit) in Aruba in 2002 to that in 2004?
Your answer should be very brief. 0.88. What is the ratio of the Imports (in Local Currency Unit) of Burundi in 2002 to that in 2004?
Your answer should be compact. 0.53. What is the ratio of the Imports (in Local Currency Unit) of India in 2002 to that in 2004?
Your answer should be compact. 0.61. What is the ratio of the Imports (in Local Currency Unit) of Netherlands in 2002 to that in 2004?
Keep it short and to the point. 0.92. What is the ratio of the Imports (in Local Currency Unit) of Aruba in 2002 to that in 2005?
Offer a terse response. 0.74. What is the ratio of the Imports (in Local Currency Unit) of Burundi in 2002 to that in 2005?
Your answer should be very brief. 0.32. What is the ratio of the Imports (in Local Currency Unit) in India in 2002 to that in 2005?
Keep it short and to the point. 0.47. What is the ratio of the Imports (in Local Currency Unit) of Netherlands in 2002 to that in 2005?
Provide a short and direct response. 0.84. What is the ratio of the Imports (in Local Currency Unit) of Aruba in 2002 to that in 2006?
Give a very brief answer. 0.71. What is the ratio of the Imports (in Local Currency Unit) of Burundi in 2002 to that in 2006?
Offer a very short reply. 0.21. What is the ratio of the Imports (in Local Currency Unit) in India in 2002 to that in 2006?
Your response must be concise. 0.37. What is the ratio of the Imports (in Local Currency Unit) in Netherlands in 2002 to that in 2006?
Your answer should be compact. 0.76. What is the ratio of the Imports (in Local Currency Unit) of Aruba in 2002 to that in 2007?
Ensure brevity in your answer.  0.67. What is the ratio of the Imports (in Local Currency Unit) in Burundi in 2002 to that in 2007?
Your answer should be compact. 0.26. What is the ratio of the Imports (in Local Currency Unit) in India in 2002 to that in 2007?
Ensure brevity in your answer.  0.31. What is the ratio of the Imports (in Local Currency Unit) of Netherlands in 2002 to that in 2007?
Ensure brevity in your answer.  0.71. What is the ratio of the Imports (in Local Currency Unit) of Aruba in 2002 to that in 2008?
Give a very brief answer. 0.64. What is the ratio of the Imports (in Local Currency Unit) of Burundi in 2002 to that in 2008?
Your answer should be very brief. 0.18. What is the ratio of the Imports (in Local Currency Unit) of India in 2002 to that in 2008?
Your answer should be compact. 0.24. What is the ratio of the Imports (in Local Currency Unit) of Netherlands in 2002 to that in 2008?
Make the answer very short. 0.66. What is the ratio of the Imports (in Local Currency Unit) of Aruba in 2002 to that in 2009?
Your answer should be compact. 0.71. What is the ratio of the Imports (in Local Currency Unit) in Burundi in 2002 to that in 2009?
Ensure brevity in your answer.  0.14. What is the ratio of the Imports (in Local Currency Unit) of India in 2002 to that in 2009?
Make the answer very short. 0.23. What is the ratio of the Imports (in Local Currency Unit) in Netherlands in 2002 to that in 2009?
Your response must be concise. 0.77. What is the ratio of the Imports (in Local Currency Unit) of Aruba in 2003 to that in 2004?
Give a very brief answer. 0.94. What is the ratio of the Imports (in Local Currency Unit) of Burundi in 2003 to that in 2004?
Offer a very short reply. 0.72. What is the ratio of the Imports (in Local Currency Unit) in India in 2003 to that in 2004?
Provide a succinct answer. 0.7. What is the ratio of the Imports (in Local Currency Unit) of Netherlands in 2003 to that in 2004?
Make the answer very short. 0.92. What is the ratio of the Imports (in Local Currency Unit) of Aruba in 2003 to that in 2005?
Make the answer very short. 0.79. What is the ratio of the Imports (in Local Currency Unit) in Burundi in 2003 to that in 2005?
Provide a short and direct response. 0.44. What is the ratio of the Imports (in Local Currency Unit) in India in 2003 to that in 2005?
Keep it short and to the point. 0.54. What is the ratio of the Imports (in Local Currency Unit) of Netherlands in 2003 to that in 2005?
Give a very brief answer. 0.85. What is the ratio of the Imports (in Local Currency Unit) of Aruba in 2003 to that in 2006?
Ensure brevity in your answer.  0.76. What is the ratio of the Imports (in Local Currency Unit) of Burundi in 2003 to that in 2006?
Ensure brevity in your answer.  0.29. What is the ratio of the Imports (in Local Currency Unit) of India in 2003 to that in 2006?
Your answer should be very brief. 0.42. What is the ratio of the Imports (in Local Currency Unit) of Netherlands in 2003 to that in 2006?
Your response must be concise. 0.76. What is the ratio of the Imports (in Local Currency Unit) in Aruba in 2003 to that in 2007?
Keep it short and to the point. 0.71. What is the ratio of the Imports (in Local Currency Unit) in Burundi in 2003 to that in 2007?
Keep it short and to the point. 0.36. What is the ratio of the Imports (in Local Currency Unit) in India in 2003 to that in 2007?
Give a very brief answer. 0.36. What is the ratio of the Imports (in Local Currency Unit) of Netherlands in 2003 to that in 2007?
Keep it short and to the point. 0.71. What is the ratio of the Imports (in Local Currency Unit) in Aruba in 2003 to that in 2008?
Keep it short and to the point. 0.68. What is the ratio of the Imports (in Local Currency Unit) of Burundi in 2003 to that in 2008?
Your response must be concise. 0.25. What is the ratio of the Imports (in Local Currency Unit) in India in 2003 to that in 2008?
Keep it short and to the point. 0.27. What is the ratio of the Imports (in Local Currency Unit) of Netherlands in 2003 to that in 2008?
Your answer should be compact. 0.67. What is the ratio of the Imports (in Local Currency Unit) in Aruba in 2003 to that in 2009?
Offer a terse response. 0.75. What is the ratio of the Imports (in Local Currency Unit) in Burundi in 2003 to that in 2009?
Offer a terse response. 0.19. What is the ratio of the Imports (in Local Currency Unit) in India in 2003 to that in 2009?
Make the answer very short. 0.27. What is the ratio of the Imports (in Local Currency Unit) of Netherlands in 2003 to that in 2009?
Your response must be concise. 0.78. What is the ratio of the Imports (in Local Currency Unit) of Aruba in 2004 to that in 2005?
Provide a succinct answer. 0.84. What is the ratio of the Imports (in Local Currency Unit) of Burundi in 2004 to that in 2005?
Provide a short and direct response. 0.61. What is the ratio of the Imports (in Local Currency Unit) of India in 2004 to that in 2005?
Offer a very short reply. 0.77. What is the ratio of the Imports (in Local Currency Unit) in Netherlands in 2004 to that in 2005?
Ensure brevity in your answer.  0.92. What is the ratio of the Imports (in Local Currency Unit) of Aruba in 2004 to that in 2006?
Make the answer very short. 0.81. What is the ratio of the Imports (in Local Currency Unit) of Burundi in 2004 to that in 2006?
Offer a terse response. 0.4. What is the ratio of the Imports (in Local Currency Unit) of India in 2004 to that in 2006?
Your answer should be very brief. 0.6. What is the ratio of the Imports (in Local Currency Unit) in Netherlands in 2004 to that in 2006?
Keep it short and to the point. 0.83. What is the ratio of the Imports (in Local Currency Unit) of Aruba in 2004 to that in 2007?
Your answer should be very brief. 0.76. What is the ratio of the Imports (in Local Currency Unit) in Burundi in 2004 to that in 2007?
Provide a short and direct response. 0.49. What is the ratio of the Imports (in Local Currency Unit) in India in 2004 to that in 2007?
Your answer should be compact. 0.51. What is the ratio of the Imports (in Local Currency Unit) in Netherlands in 2004 to that in 2007?
Offer a very short reply. 0.77. What is the ratio of the Imports (in Local Currency Unit) in Aruba in 2004 to that in 2008?
Give a very brief answer. 0.73. What is the ratio of the Imports (in Local Currency Unit) in Burundi in 2004 to that in 2008?
Your response must be concise. 0.34. What is the ratio of the Imports (in Local Currency Unit) in India in 2004 to that in 2008?
Provide a succinct answer. 0.39. What is the ratio of the Imports (in Local Currency Unit) in Netherlands in 2004 to that in 2008?
Provide a succinct answer. 0.72. What is the ratio of the Imports (in Local Currency Unit) of Aruba in 2004 to that in 2009?
Keep it short and to the point. 0.8. What is the ratio of the Imports (in Local Currency Unit) in Burundi in 2004 to that in 2009?
Your answer should be very brief. 0.27. What is the ratio of the Imports (in Local Currency Unit) in India in 2004 to that in 2009?
Ensure brevity in your answer.  0.38. What is the ratio of the Imports (in Local Currency Unit) of Netherlands in 2004 to that in 2009?
Make the answer very short. 0.85. What is the ratio of the Imports (in Local Currency Unit) in Aruba in 2005 to that in 2006?
Your answer should be compact. 0.96. What is the ratio of the Imports (in Local Currency Unit) in Burundi in 2005 to that in 2006?
Provide a short and direct response. 0.66. What is the ratio of the Imports (in Local Currency Unit) of India in 2005 to that in 2006?
Make the answer very short. 0.78. What is the ratio of the Imports (in Local Currency Unit) of Netherlands in 2005 to that in 2006?
Provide a short and direct response. 0.9. What is the ratio of the Imports (in Local Currency Unit) in Aruba in 2005 to that in 2007?
Provide a succinct answer. 0.91. What is the ratio of the Imports (in Local Currency Unit) of Burundi in 2005 to that in 2007?
Your answer should be compact. 0.8. What is the ratio of the Imports (in Local Currency Unit) of India in 2005 to that in 2007?
Your answer should be very brief. 0.67. What is the ratio of the Imports (in Local Currency Unit) of Netherlands in 2005 to that in 2007?
Your answer should be compact. 0.84. What is the ratio of the Imports (in Local Currency Unit) in Aruba in 2005 to that in 2008?
Give a very brief answer. 0.87. What is the ratio of the Imports (in Local Currency Unit) in Burundi in 2005 to that in 2008?
Your response must be concise. 0.56. What is the ratio of the Imports (in Local Currency Unit) in India in 2005 to that in 2008?
Provide a short and direct response. 0.5. What is the ratio of the Imports (in Local Currency Unit) in Netherlands in 2005 to that in 2008?
Provide a short and direct response. 0.78. What is the ratio of the Imports (in Local Currency Unit) in Aruba in 2005 to that in 2009?
Keep it short and to the point. 0.95. What is the ratio of the Imports (in Local Currency Unit) in Burundi in 2005 to that in 2009?
Your response must be concise. 0.44. What is the ratio of the Imports (in Local Currency Unit) in India in 2005 to that in 2009?
Provide a short and direct response. 0.49. What is the ratio of the Imports (in Local Currency Unit) of Netherlands in 2005 to that in 2009?
Provide a succinct answer. 0.92. What is the ratio of the Imports (in Local Currency Unit) in Aruba in 2006 to that in 2007?
Give a very brief answer. 0.94. What is the ratio of the Imports (in Local Currency Unit) in Burundi in 2006 to that in 2007?
Offer a very short reply. 1.22. What is the ratio of the Imports (in Local Currency Unit) of India in 2006 to that in 2007?
Offer a terse response. 0.85. What is the ratio of the Imports (in Local Currency Unit) of Netherlands in 2006 to that in 2007?
Make the answer very short. 0.93. What is the ratio of the Imports (in Local Currency Unit) in Aruba in 2006 to that in 2008?
Provide a short and direct response. 0.9. What is the ratio of the Imports (in Local Currency Unit) in Burundi in 2006 to that in 2008?
Your answer should be compact. 0.85. What is the ratio of the Imports (in Local Currency Unit) of India in 2006 to that in 2008?
Your answer should be very brief. 0.64. What is the ratio of the Imports (in Local Currency Unit) of Netherlands in 2006 to that in 2008?
Offer a terse response. 0.87. What is the ratio of the Imports (in Local Currency Unit) of Aruba in 2006 to that in 2009?
Provide a succinct answer. 0.99. What is the ratio of the Imports (in Local Currency Unit) in Burundi in 2006 to that in 2009?
Your answer should be very brief. 0.67. What is the ratio of the Imports (in Local Currency Unit) in India in 2006 to that in 2009?
Your response must be concise. 0.63. What is the ratio of the Imports (in Local Currency Unit) in Netherlands in 2006 to that in 2009?
Give a very brief answer. 1.02. What is the ratio of the Imports (in Local Currency Unit) in Aruba in 2007 to that in 2008?
Ensure brevity in your answer.  0.96. What is the ratio of the Imports (in Local Currency Unit) of Burundi in 2007 to that in 2008?
Make the answer very short. 0.69. What is the ratio of the Imports (in Local Currency Unit) in India in 2007 to that in 2008?
Make the answer very short. 0.76. What is the ratio of the Imports (in Local Currency Unit) in Netherlands in 2007 to that in 2008?
Your answer should be compact. 0.94. What is the ratio of the Imports (in Local Currency Unit) in Aruba in 2007 to that in 2009?
Your answer should be compact. 1.05. What is the ratio of the Imports (in Local Currency Unit) in Burundi in 2007 to that in 2009?
Make the answer very short. 0.54. What is the ratio of the Imports (in Local Currency Unit) of India in 2007 to that in 2009?
Offer a very short reply. 0.74. What is the ratio of the Imports (in Local Currency Unit) of Netherlands in 2007 to that in 2009?
Provide a succinct answer. 1.09. What is the ratio of the Imports (in Local Currency Unit) in Aruba in 2008 to that in 2009?
Provide a short and direct response. 1.1. What is the ratio of the Imports (in Local Currency Unit) of Burundi in 2008 to that in 2009?
Offer a very short reply. 0.79. What is the ratio of the Imports (in Local Currency Unit) in India in 2008 to that in 2009?
Your answer should be very brief. 0.98. What is the ratio of the Imports (in Local Currency Unit) in Netherlands in 2008 to that in 2009?
Make the answer very short. 1.17. What is the difference between the highest and the second highest Imports (in Local Currency Unit) in Aruba?
Offer a terse response. 1.54e+08. What is the difference between the highest and the second highest Imports (in Local Currency Unit) of Burundi?
Give a very brief answer. 1.98e+11. What is the difference between the highest and the second highest Imports (in Local Currency Unit) of India?
Give a very brief answer. 3.31e+11. What is the difference between the highest and the second highest Imports (in Local Currency Unit) in Netherlands?
Offer a very short reply. 2.59e+1. What is the difference between the highest and the lowest Imports (in Local Currency Unit) of Aruba?
Make the answer very short. 1.33e+09. What is the difference between the highest and the lowest Imports (in Local Currency Unit) of Burundi?
Provide a short and direct response. 7.92e+11. What is the difference between the highest and the lowest Imports (in Local Currency Unit) of India?
Give a very brief answer. 1.27e+13. What is the difference between the highest and the lowest Imports (in Local Currency Unit) of Netherlands?
Provide a succinct answer. 1.36e+11. 